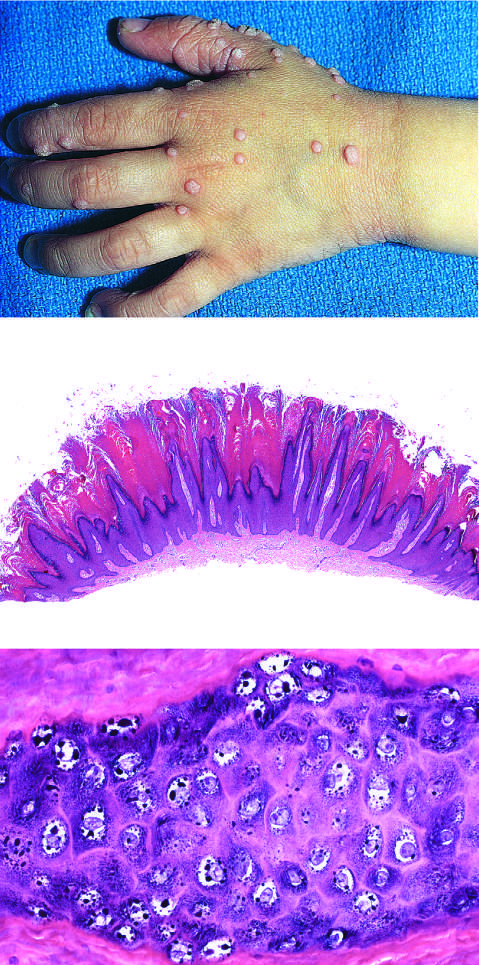what do common warts contain?
Answer the question using a single word or phrase. Zones of papillary epidermal proliferation 